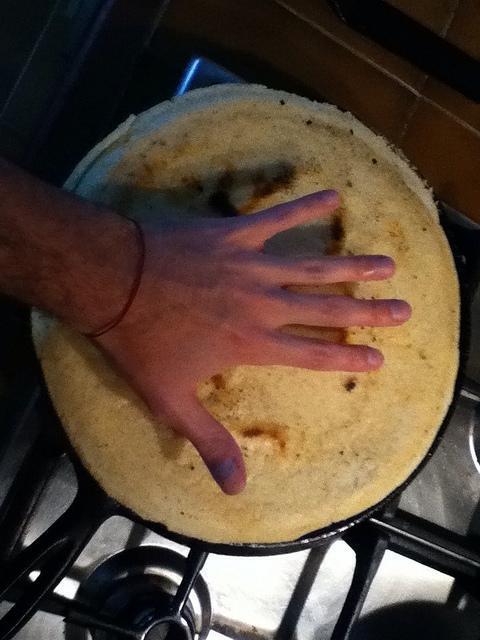How many clocks are in the photo?
Give a very brief answer. 0. 